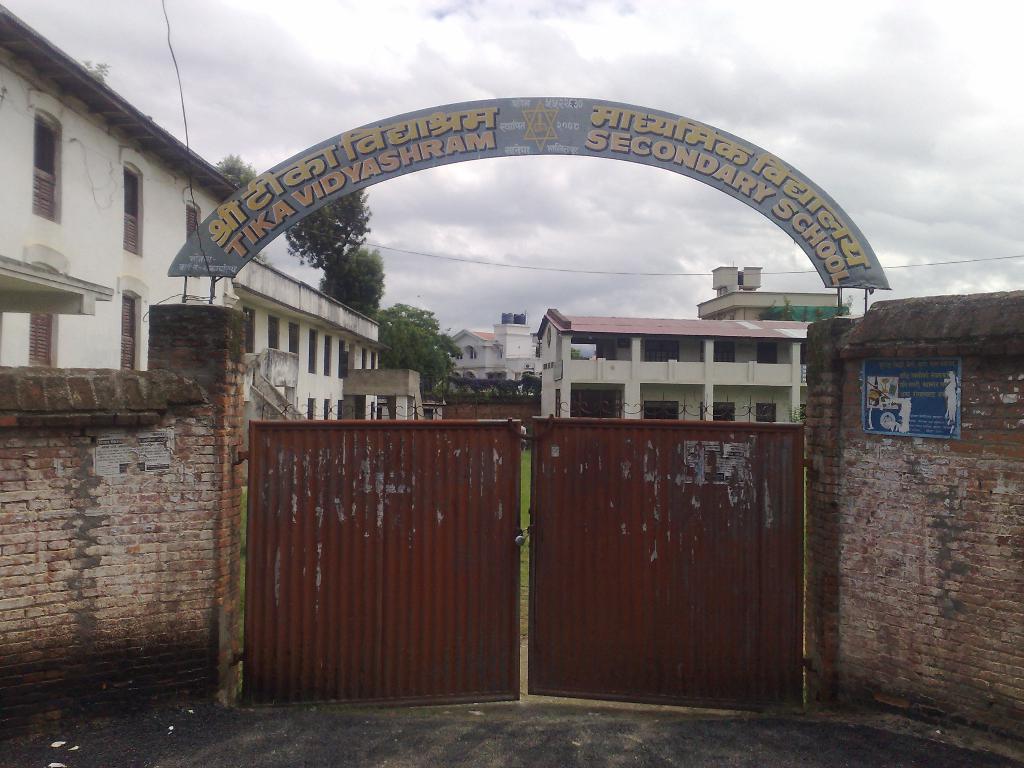Can you describe this image briefly? There is a red gate with a lock. Also two brick walls on the two sides. Also there is an arc of a secondary school. In the background it is a secondary school. Also there are trees and sky in the background. 